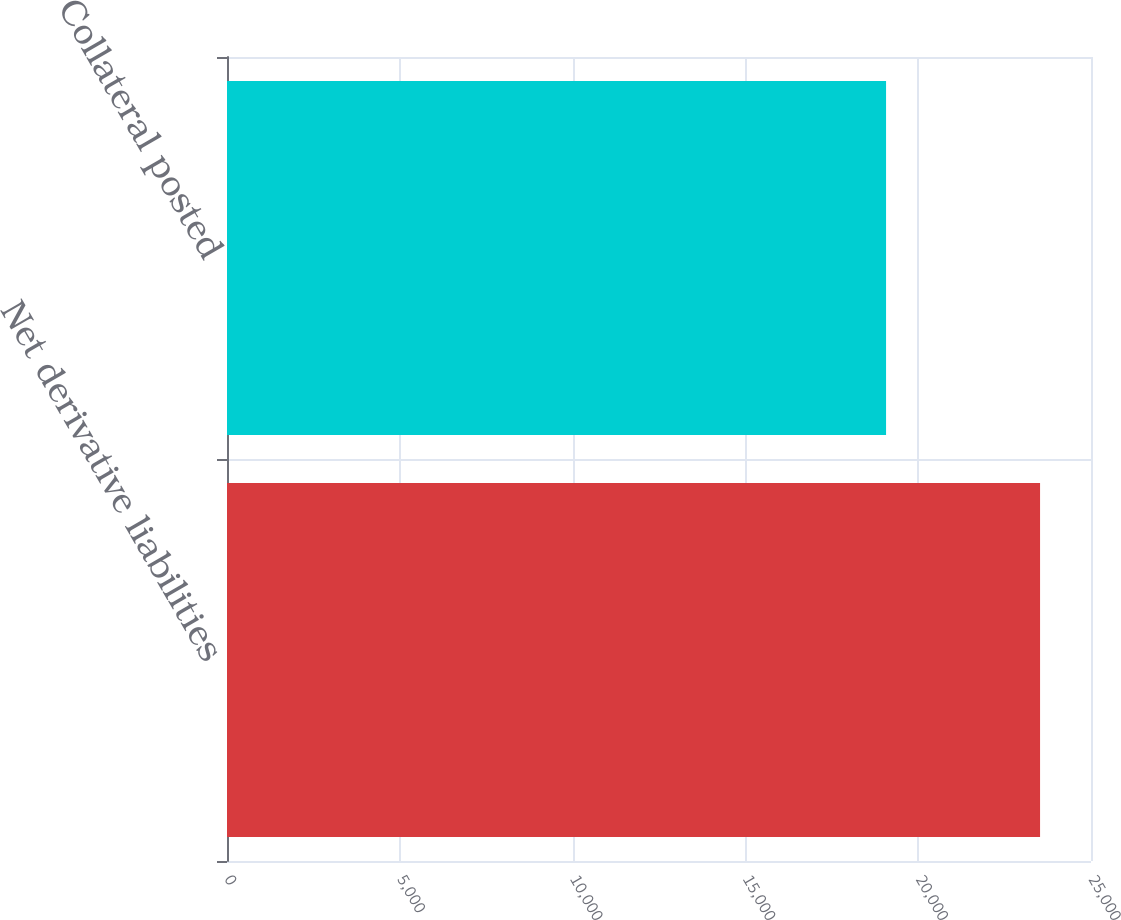Convert chart to OTSL. <chart><loc_0><loc_0><loc_500><loc_500><bar_chart><fcel>Net derivative liabilities<fcel>Collateral posted<nl><fcel>23526<fcel>19070<nl></chart> 